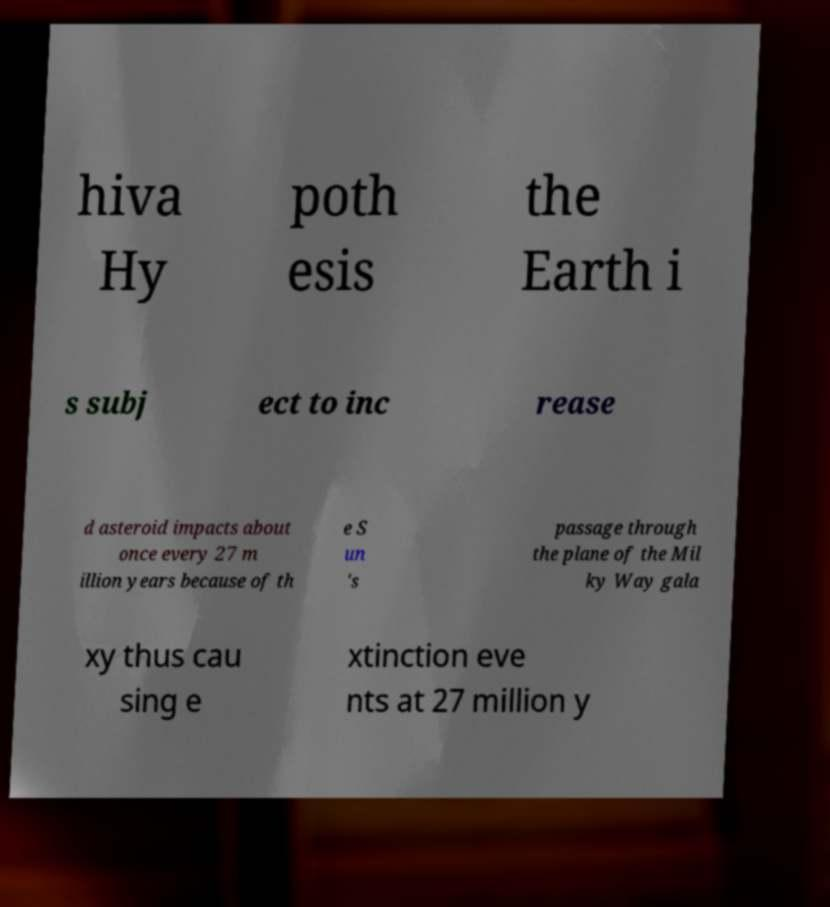Can you accurately transcribe the text from the provided image for me? hiva Hy poth esis the Earth i s subj ect to inc rease d asteroid impacts about once every 27 m illion years because of th e S un 's passage through the plane of the Mil ky Way gala xy thus cau sing e xtinction eve nts at 27 million y 